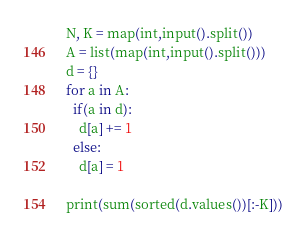<code> <loc_0><loc_0><loc_500><loc_500><_Python_>N, K = map(int,input().split())
A = list(map(int,input().split()))
d = {}
for a in A:
  if(a in d):
    d[a] += 1
  else:
    d[a] = 1

print(sum(sorted(d.values())[:-K]))</code> 